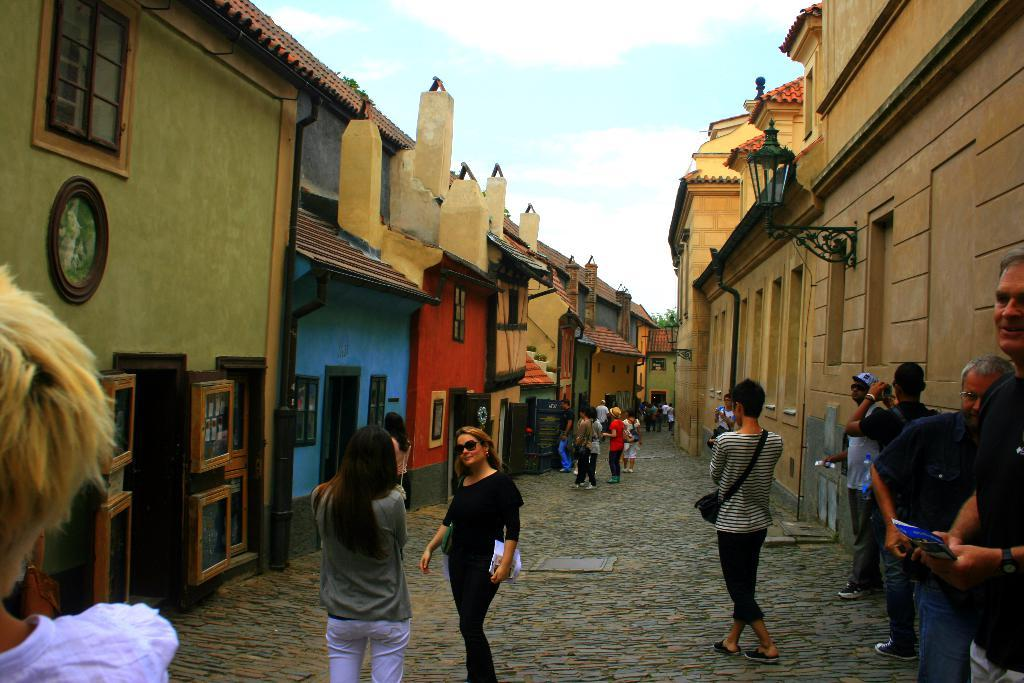What are the people in the image doing? The people in the image are on a path. What structures can be seen in the image? There are buildings in the image. What type of objects are present in the image? There are boards and lights in the image. What architectural features can be observed in the buildings? There are windows in the buildings. What else is visible in the image? There are objects and leaves in the image. What can be seen in the background of the image? The sky is visible in the background of the image. How many clocks are visible in the image? There are no clocks present in the image. What type of oil is being used to illuminate the lights in the image? There is no oil being used to illuminate the lights in the image; they are likely powered by electricity. 